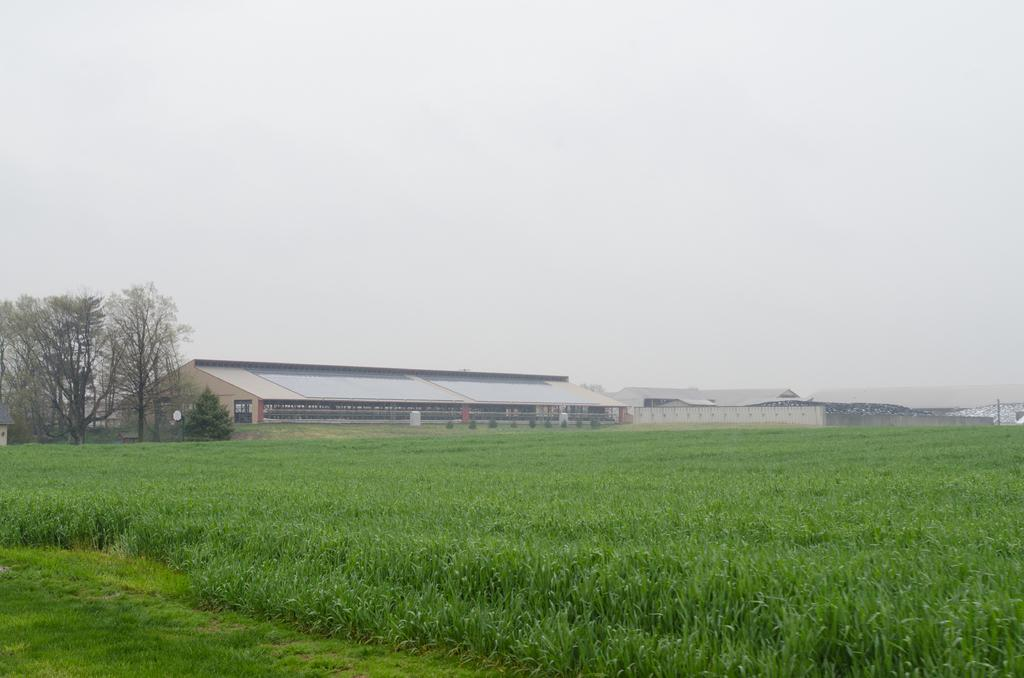What type of vegetation is present at the bottom of the image? There are plants and grass at the bottom of the image. What structures can be seen in the background of the image? There are houses and trees in the background of the image. What is visible at the top of the image? The sky is visible at the top of the image. What type of lumber is being used to build the houses in the image? There is no information about the type of lumber used to build the houses in the image. How far does the range of the plants extend in the image? The image does not provide information about the range of the plants. 